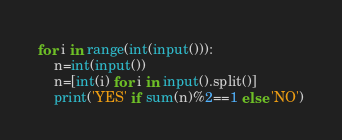<code> <loc_0><loc_0><loc_500><loc_500><_Python_>for i in range(int(input())):
    n=int(input())
    n=[int(i) for i in input().split()]
    print('YES' if sum(n)%2==1 else 'NO')
</code> 